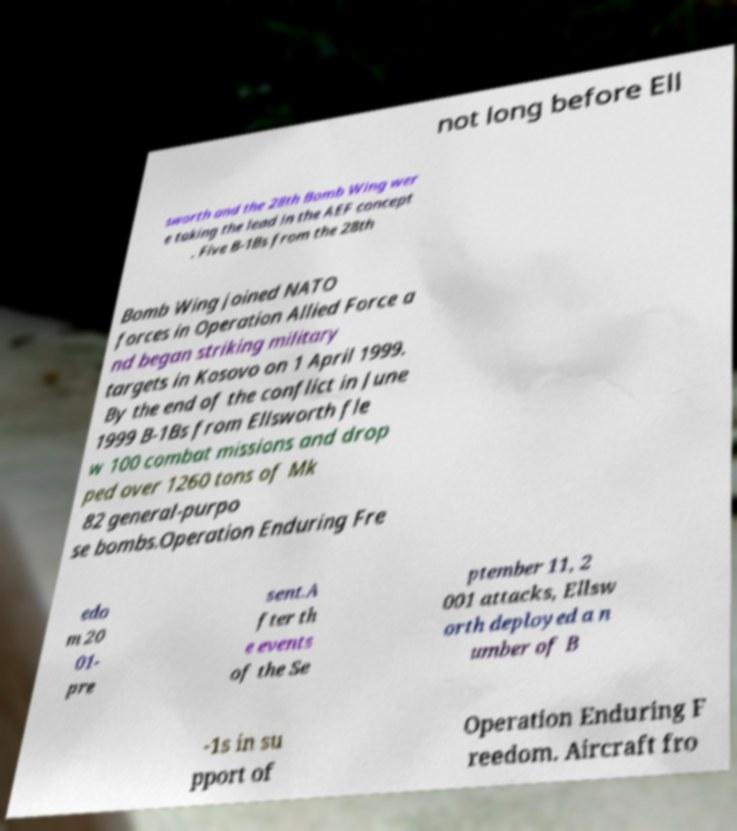What messages or text are displayed in this image? I need them in a readable, typed format. not long before Ell sworth and the 28th Bomb Wing wer e taking the lead in the AEF concept . Five B-1Bs from the 28th Bomb Wing joined NATO forces in Operation Allied Force a nd began striking military targets in Kosovo on 1 April 1999. By the end of the conflict in June 1999 B-1Bs from Ellsworth fle w 100 combat missions and drop ped over 1260 tons of Mk 82 general-purpo se bombs.Operation Enduring Fre edo m 20 01- pre sent.A fter th e events of the Se ptember 11, 2 001 attacks, Ellsw orth deployed a n umber of B -1s in su pport of Operation Enduring F reedom. Aircraft fro 